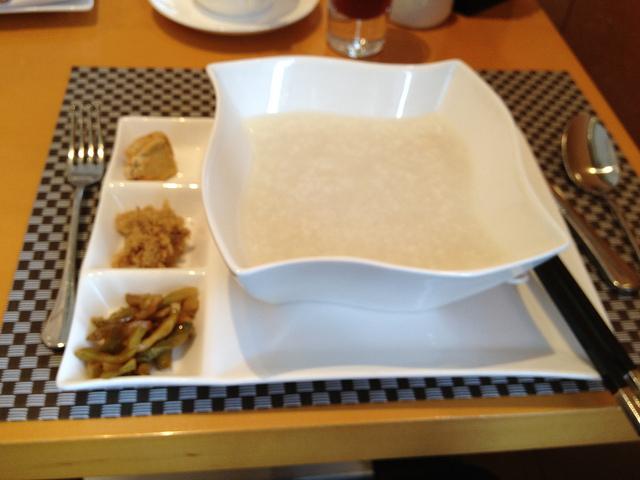Is the fork on the left or the right of the plate?
Answer briefly. Left. What utensils are on the right side?
Short answer required. Knife and spoon. How many sides are there to the dish?
Concise answer only. 3. 